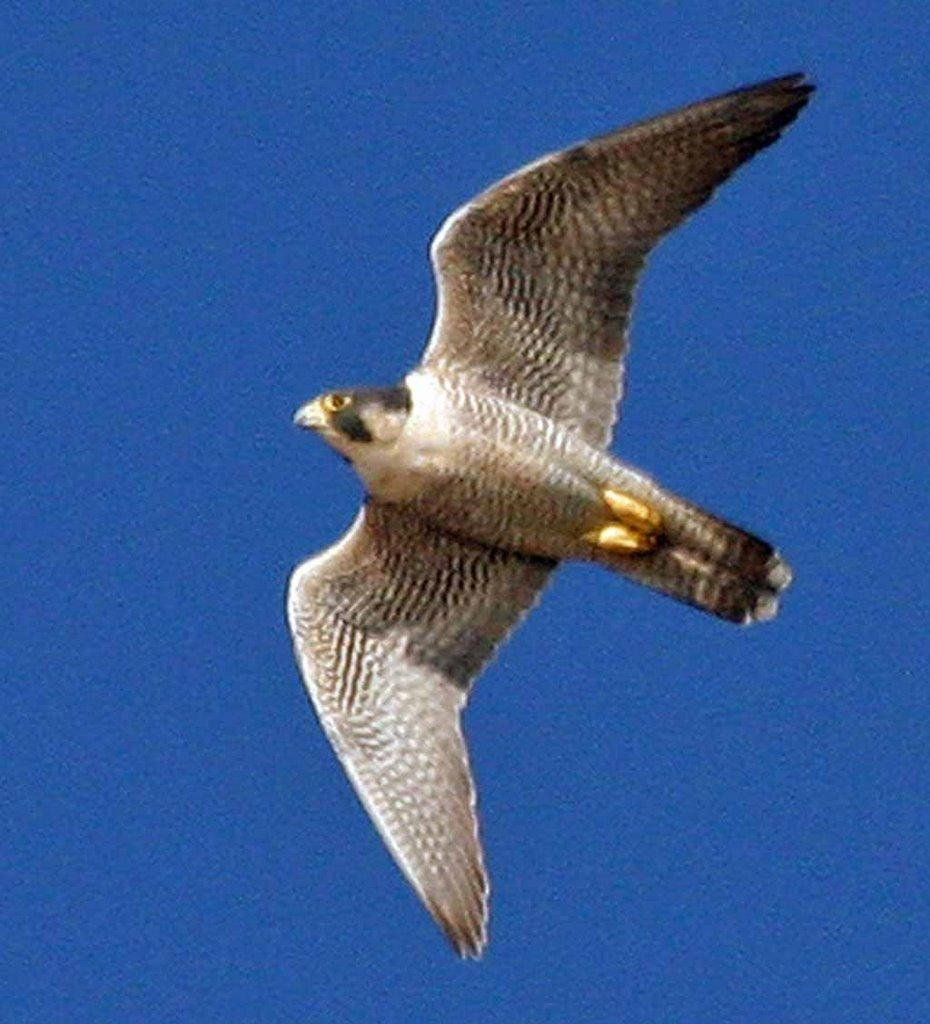What type of bird is in the image? There is an eagle in the image. Can you see the eagle's nest in the image? There is no nest visible in the image; only the eagle is present. Is the eagle stuck in quicksand in the image? There is no quicksand present in the image, and the eagle is not depicted in any precarious situation. 